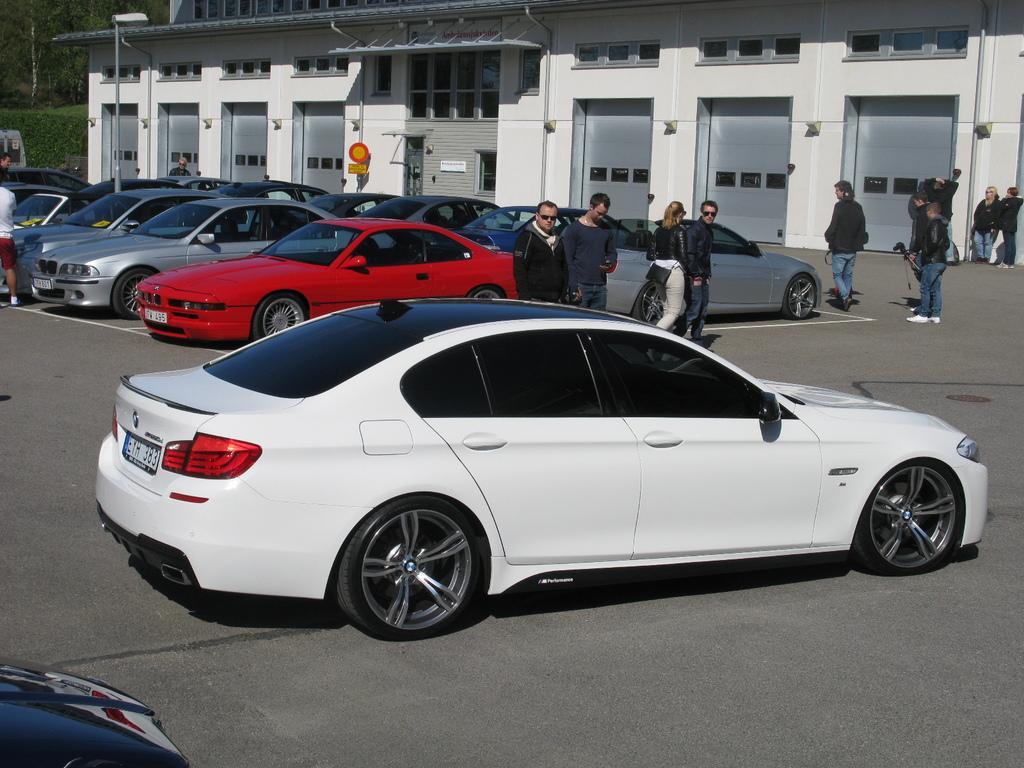Can you describe this image briefly? In this image we can see a few cars on the road, there are some persons standing around them, also we can see a building, windows, doors, shutters, lights, poles, plants, and trees. 